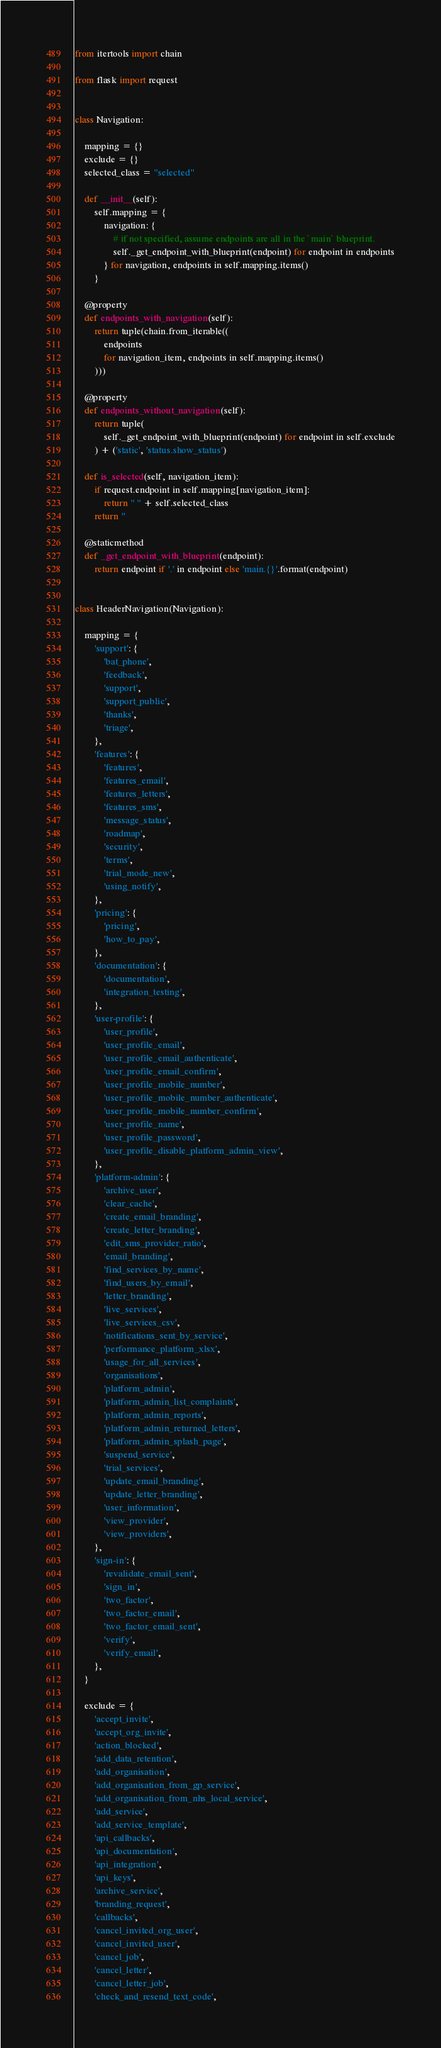Convert code to text. <code><loc_0><loc_0><loc_500><loc_500><_Python_>from itertools import chain

from flask import request


class Navigation:

    mapping = {}
    exclude = {}
    selected_class = "selected"

    def __init__(self):
        self.mapping = {
            navigation: {
                # if not specified, assume endpoints are all in the `main` blueprint.
                self._get_endpoint_with_blueprint(endpoint) for endpoint in endpoints
            } for navigation, endpoints in self.mapping.items()
        }

    @property
    def endpoints_with_navigation(self):
        return tuple(chain.from_iterable((
            endpoints
            for navigation_item, endpoints in self.mapping.items()
        )))

    @property
    def endpoints_without_navigation(self):
        return tuple(
            self._get_endpoint_with_blueprint(endpoint) for endpoint in self.exclude
        ) + ('static', 'status.show_status')

    def is_selected(self, navigation_item):
        if request.endpoint in self.mapping[navigation_item]:
            return " " + self.selected_class
        return ''

    @staticmethod
    def _get_endpoint_with_blueprint(endpoint):
        return endpoint if '.' in endpoint else 'main.{}'.format(endpoint)


class HeaderNavigation(Navigation):

    mapping = {
        'support': {
            'bat_phone',
            'feedback',
            'support',
            'support_public',
            'thanks',
            'triage',
        },
        'features': {
            'features',
            'features_email',
            'features_letters',
            'features_sms',
            'message_status',
            'roadmap',
            'security',
            'terms',
            'trial_mode_new',
            'using_notify',
        },
        'pricing': {
            'pricing',
            'how_to_pay',
        },
        'documentation': {
            'documentation',
            'integration_testing',
        },
        'user-profile': {
            'user_profile',
            'user_profile_email',
            'user_profile_email_authenticate',
            'user_profile_email_confirm',
            'user_profile_mobile_number',
            'user_profile_mobile_number_authenticate',
            'user_profile_mobile_number_confirm',
            'user_profile_name',
            'user_profile_password',
            'user_profile_disable_platform_admin_view',
        },
        'platform-admin': {
            'archive_user',
            'clear_cache',
            'create_email_branding',
            'create_letter_branding',
            'edit_sms_provider_ratio',
            'email_branding',
            'find_services_by_name',
            'find_users_by_email',
            'letter_branding',
            'live_services',
            'live_services_csv',
            'notifications_sent_by_service',
            'performance_platform_xlsx',
            'usage_for_all_services',
            'organisations',
            'platform_admin',
            'platform_admin_list_complaints',
            'platform_admin_reports',
            'platform_admin_returned_letters',
            'platform_admin_splash_page',
            'suspend_service',
            'trial_services',
            'update_email_branding',
            'update_letter_branding',
            'user_information',
            'view_provider',
            'view_providers',
        },
        'sign-in': {
            'revalidate_email_sent',
            'sign_in',
            'two_factor',
            'two_factor_email',
            'two_factor_email_sent',
            'verify',
            'verify_email',
        },
    }

    exclude = {
        'accept_invite',
        'accept_org_invite',
        'action_blocked',
        'add_data_retention',
        'add_organisation',
        'add_organisation_from_gp_service',
        'add_organisation_from_nhs_local_service',
        'add_service',
        'add_service_template',
        'api_callbacks',
        'api_documentation',
        'api_integration',
        'api_keys',
        'archive_service',
        'branding_request',
        'callbacks',
        'cancel_invited_org_user',
        'cancel_invited_user',
        'cancel_job',
        'cancel_letter',
        'cancel_letter_job',
        'check_and_resend_text_code',</code> 